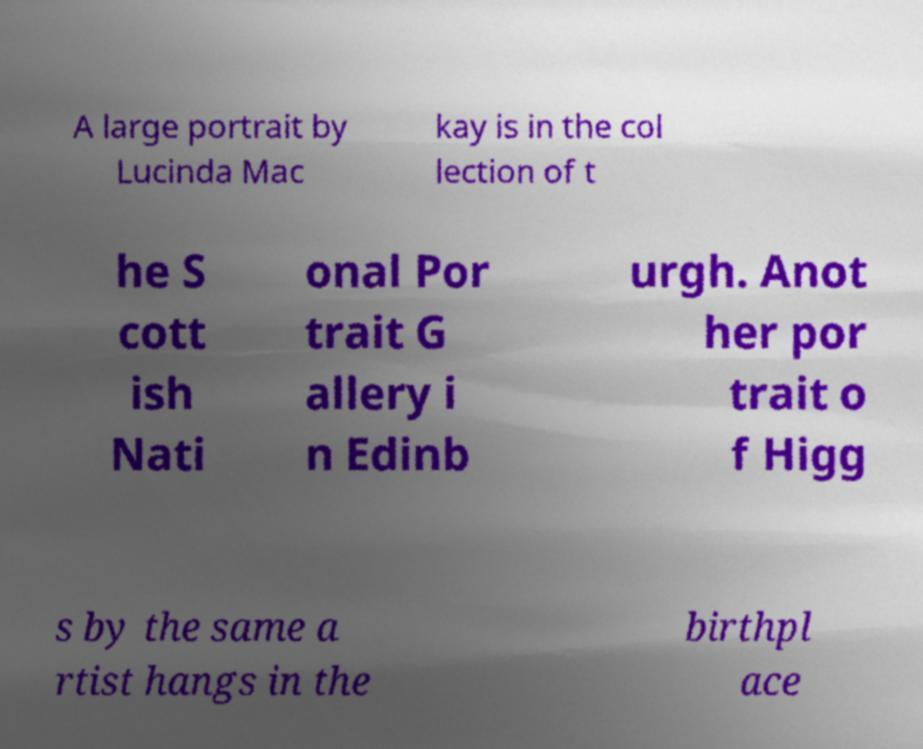What messages or text are displayed in this image? I need them in a readable, typed format. A large portrait by Lucinda Mac kay is in the col lection of t he S cott ish Nati onal Por trait G allery i n Edinb urgh. Anot her por trait o f Higg s by the same a rtist hangs in the birthpl ace 